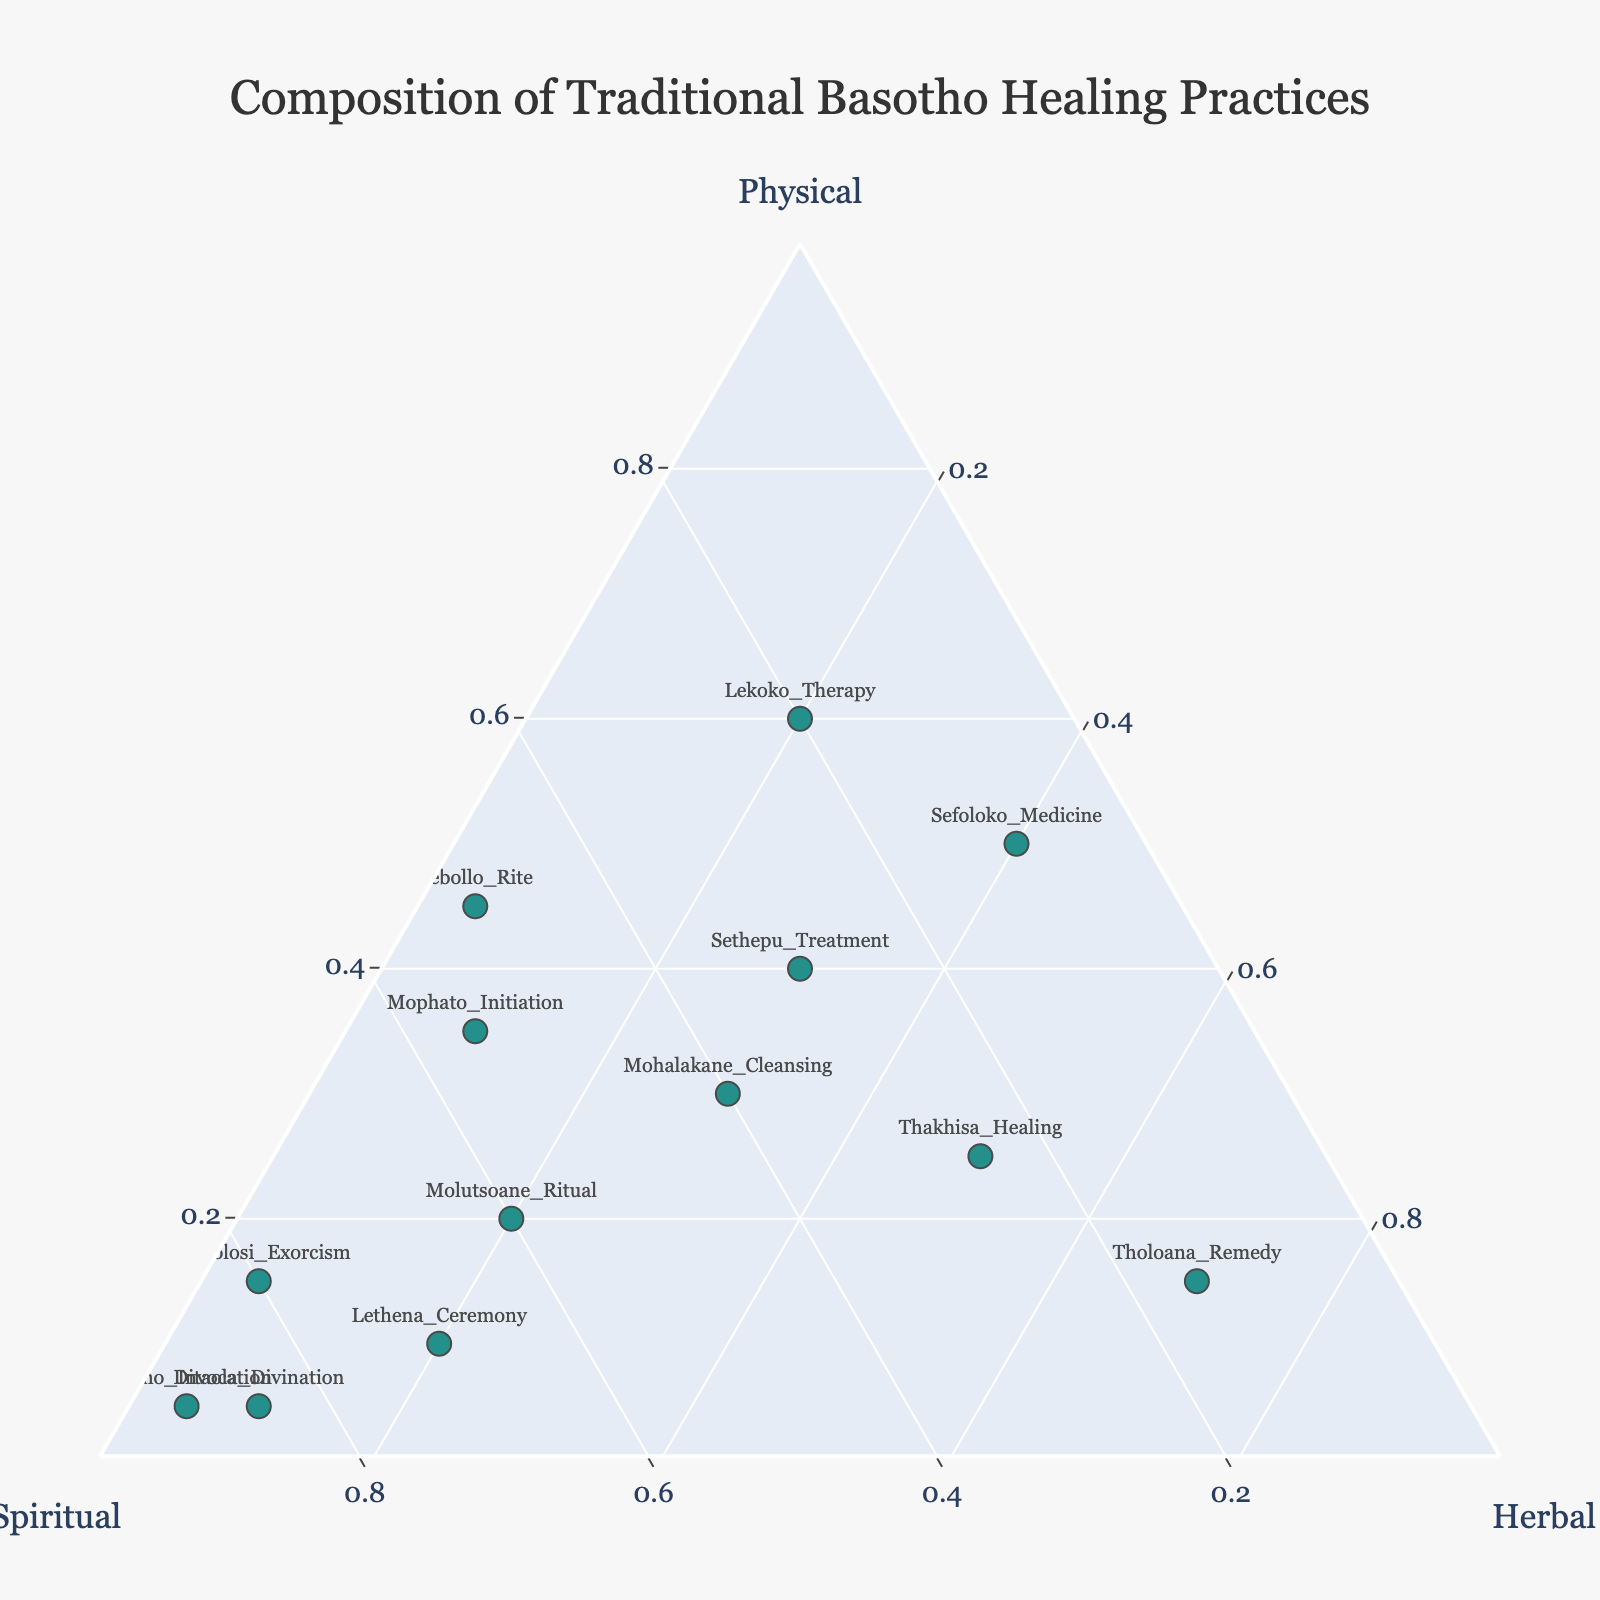How many healing practices are depicted in the ternary plot? The plot shows individual data points representing different healing practices. Count the number of labels corresponding to these points.
Answer: 13 Which healing practice has the highest spiritual component? Identify the data point closest to the 'Spiritual' vertex of the ternary plot, which represents the highest spiritual component.
Answer: Balimo Invocation Is Sethepu Treatment more of a physical practice or a spiritual practice? Locate the Sethepu Treatment on the ternary plot and compare its distance to the 'Physical' and 'Spiritual' vertices. It is closer to the Physical vertex.
Answer: Physical practice Which healing practices have the same composition for Physical and Herbal components? Find the data points where the physical and herbal percentages are equal. Check the labels associated with these points.
Answer: Sethepu Treatment, Mohalakane Cleansing, Thakhisa Healing What is the sum value range of the practices on the plot? Look at the color values tied to the scales which represent the sum and note the range from lowest to highest.
Answer: 10 to 100 Which practice is more balanced, Mohalakane Cleansing or Tholoana Remedy? Locate the two practices. Mohalakane Cleansing has relatively equal distribution between physical, spiritual, and herbal components.
Answer: Mohalakane Cleansing How many healing practices have a greater physical component than Sethepu Treatment? Identify healing practices placed to the right of Sethepu Treatment (higher on the Physical axis). Count these points.
Answer: 2 Which ceremony involves a primarily spiritual approach? Find ceremonies situated closest to the Spiritual vertex.
Answer: Lethena Ceremony What is the average herbal component of all practices? Sum herbal percentages of all practices (20+20+30+5+5+30+10+40+20+50+10+5+70) and divide by the number of practices (13).
Answer: Approx. 24.62% Is Thakhisa Healing more herbal inclined than Ditaola Divination? Compare the herbal component distances of Thakhisa Healing and Ditaola Divination from the Herbal vertex. Thakhisa Healing is closer.
Answer: Yes 